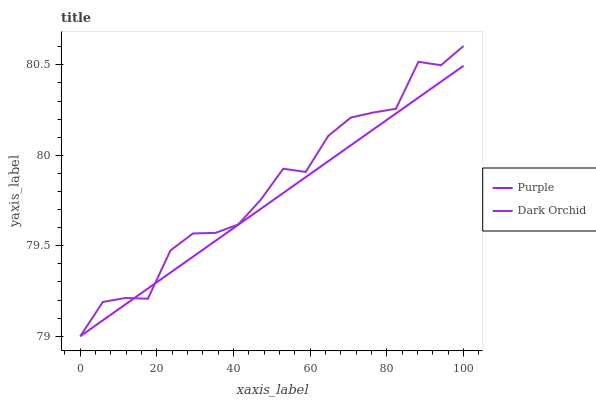Does Purple have the minimum area under the curve?
Answer yes or no. Yes. Does Dark Orchid have the maximum area under the curve?
Answer yes or no. Yes. Does Dark Orchid have the minimum area under the curve?
Answer yes or no. No. Is Purple the smoothest?
Answer yes or no. Yes. Is Dark Orchid the roughest?
Answer yes or no. Yes. Is Dark Orchid the smoothest?
Answer yes or no. No. Does Purple have the lowest value?
Answer yes or no. Yes. Does Dark Orchid have the highest value?
Answer yes or no. Yes. Does Purple intersect Dark Orchid?
Answer yes or no. Yes. Is Purple less than Dark Orchid?
Answer yes or no. No. Is Purple greater than Dark Orchid?
Answer yes or no. No. 